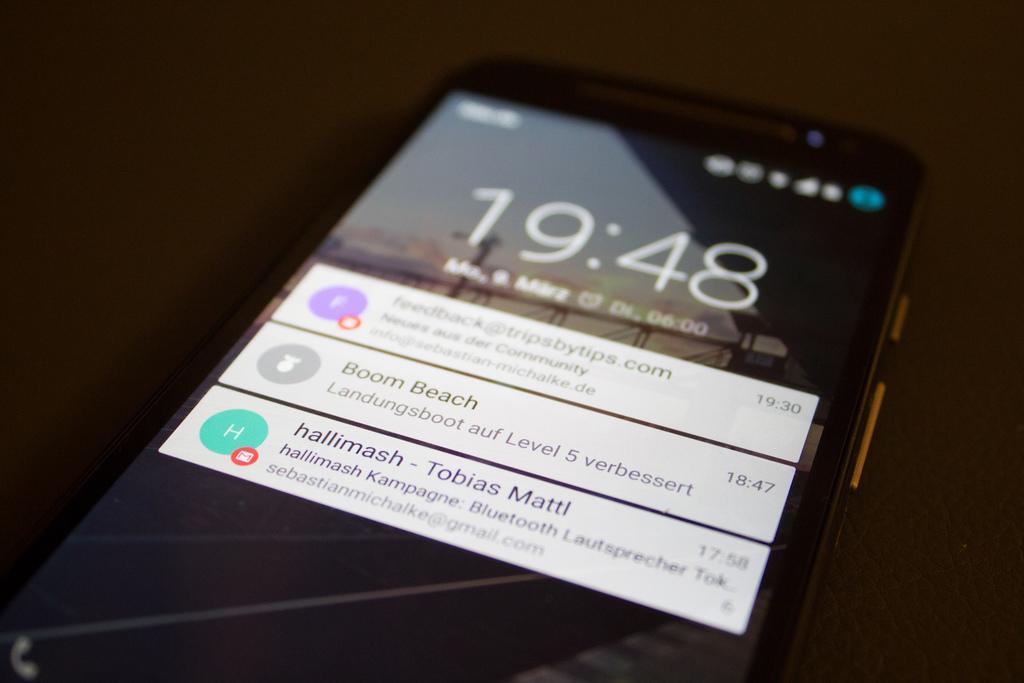Could you give a brief overview of what you see in this image? In this image, I can see a mobile with a screen. I can see the notifications, time and few other symbols on the mobile screen. There is a blurred background. 